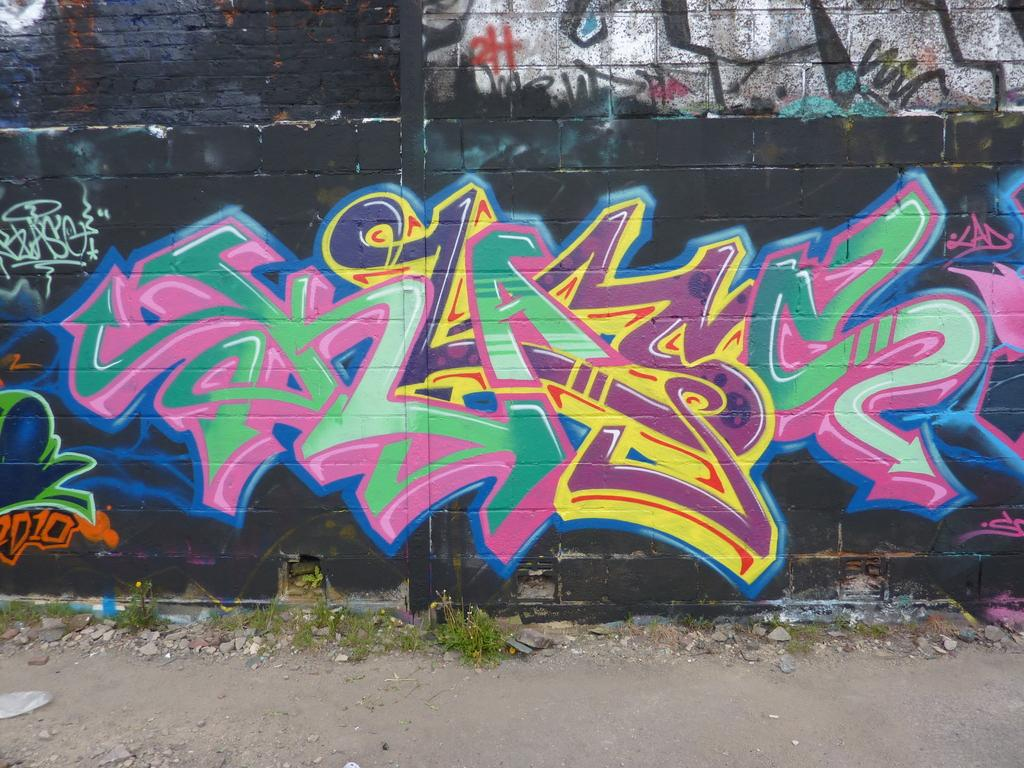What type of living organisms can be seen in the image? Plants can be seen in the image. What can be found on the ground in the image? There are stones on the ground in the image. What is on the wall in the image? There is a painting on the wall in the image. What type of nerve can be seen in the image? There is no nerve present in the image. Is there a calendar visible in the image? There is no calendar present in the image. 